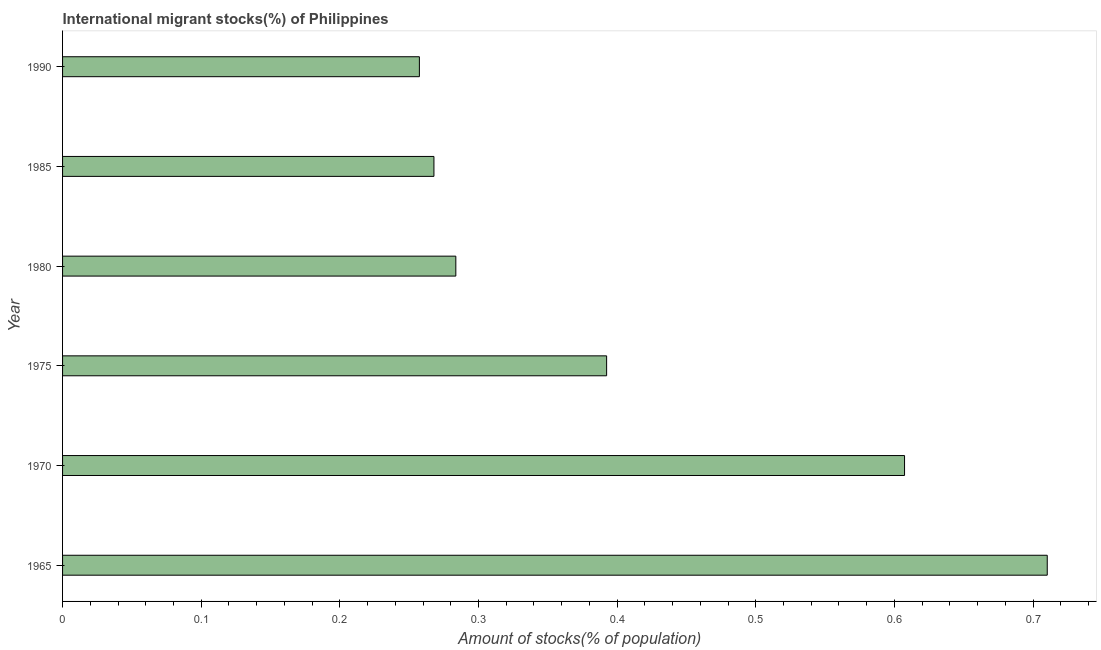Does the graph contain any zero values?
Ensure brevity in your answer.  No. Does the graph contain grids?
Keep it short and to the point. No. What is the title of the graph?
Offer a terse response. International migrant stocks(%) of Philippines. What is the label or title of the X-axis?
Ensure brevity in your answer.  Amount of stocks(% of population). What is the label or title of the Y-axis?
Offer a terse response. Year. What is the number of international migrant stocks in 1965?
Make the answer very short. 0.71. Across all years, what is the maximum number of international migrant stocks?
Ensure brevity in your answer.  0.71. Across all years, what is the minimum number of international migrant stocks?
Provide a short and direct response. 0.26. In which year was the number of international migrant stocks maximum?
Offer a terse response. 1965. In which year was the number of international migrant stocks minimum?
Offer a terse response. 1990. What is the sum of the number of international migrant stocks?
Your response must be concise. 2.52. What is the difference between the number of international migrant stocks in 1970 and 1985?
Keep it short and to the point. 0.34. What is the average number of international migrant stocks per year?
Your answer should be very brief. 0.42. What is the median number of international migrant stocks?
Your response must be concise. 0.34. Do a majority of the years between 1965 and 1970 (inclusive) have number of international migrant stocks greater than 0.54 %?
Keep it short and to the point. Yes. What is the ratio of the number of international migrant stocks in 1975 to that in 1990?
Provide a short and direct response. 1.52. Is the number of international migrant stocks in 1985 less than that in 1990?
Provide a succinct answer. No. What is the difference between the highest and the second highest number of international migrant stocks?
Provide a short and direct response. 0.1. Is the sum of the number of international migrant stocks in 1970 and 1980 greater than the maximum number of international migrant stocks across all years?
Keep it short and to the point. Yes. What is the difference between the highest and the lowest number of international migrant stocks?
Offer a terse response. 0.45. How many bars are there?
Offer a terse response. 6. Are all the bars in the graph horizontal?
Your answer should be very brief. Yes. What is the difference between two consecutive major ticks on the X-axis?
Keep it short and to the point. 0.1. What is the Amount of stocks(% of population) in 1965?
Your answer should be very brief. 0.71. What is the Amount of stocks(% of population) in 1970?
Offer a terse response. 0.61. What is the Amount of stocks(% of population) in 1975?
Your answer should be very brief. 0.39. What is the Amount of stocks(% of population) in 1980?
Your response must be concise. 0.28. What is the Amount of stocks(% of population) of 1985?
Provide a succinct answer. 0.27. What is the Amount of stocks(% of population) of 1990?
Your response must be concise. 0.26. What is the difference between the Amount of stocks(% of population) in 1965 and 1970?
Make the answer very short. 0.1. What is the difference between the Amount of stocks(% of population) in 1965 and 1975?
Give a very brief answer. 0.32. What is the difference between the Amount of stocks(% of population) in 1965 and 1980?
Provide a short and direct response. 0.43. What is the difference between the Amount of stocks(% of population) in 1965 and 1985?
Ensure brevity in your answer.  0.44. What is the difference between the Amount of stocks(% of population) in 1965 and 1990?
Your answer should be very brief. 0.45. What is the difference between the Amount of stocks(% of population) in 1970 and 1975?
Offer a very short reply. 0.21. What is the difference between the Amount of stocks(% of population) in 1970 and 1980?
Your answer should be very brief. 0.32. What is the difference between the Amount of stocks(% of population) in 1970 and 1985?
Your answer should be compact. 0.34. What is the difference between the Amount of stocks(% of population) in 1970 and 1990?
Make the answer very short. 0.35. What is the difference between the Amount of stocks(% of population) in 1975 and 1980?
Provide a short and direct response. 0.11. What is the difference between the Amount of stocks(% of population) in 1975 and 1985?
Keep it short and to the point. 0.12. What is the difference between the Amount of stocks(% of population) in 1975 and 1990?
Your answer should be very brief. 0.14. What is the difference between the Amount of stocks(% of population) in 1980 and 1985?
Offer a terse response. 0.02. What is the difference between the Amount of stocks(% of population) in 1980 and 1990?
Offer a terse response. 0.03. What is the difference between the Amount of stocks(% of population) in 1985 and 1990?
Offer a very short reply. 0.01. What is the ratio of the Amount of stocks(% of population) in 1965 to that in 1970?
Provide a succinct answer. 1.17. What is the ratio of the Amount of stocks(% of population) in 1965 to that in 1975?
Your response must be concise. 1.81. What is the ratio of the Amount of stocks(% of population) in 1965 to that in 1980?
Provide a short and direct response. 2.5. What is the ratio of the Amount of stocks(% of population) in 1965 to that in 1985?
Ensure brevity in your answer.  2.65. What is the ratio of the Amount of stocks(% of population) in 1965 to that in 1990?
Offer a very short reply. 2.76. What is the ratio of the Amount of stocks(% of population) in 1970 to that in 1975?
Give a very brief answer. 1.55. What is the ratio of the Amount of stocks(% of population) in 1970 to that in 1980?
Ensure brevity in your answer.  2.14. What is the ratio of the Amount of stocks(% of population) in 1970 to that in 1985?
Provide a succinct answer. 2.27. What is the ratio of the Amount of stocks(% of population) in 1970 to that in 1990?
Provide a succinct answer. 2.36. What is the ratio of the Amount of stocks(% of population) in 1975 to that in 1980?
Make the answer very short. 1.38. What is the ratio of the Amount of stocks(% of population) in 1975 to that in 1985?
Your answer should be very brief. 1.47. What is the ratio of the Amount of stocks(% of population) in 1975 to that in 1990?
Offer a very short reply. 1.52. What is the ratio of the Amount of stocks(% of population) in 1980 to that in 1985?
Your response must be concise. 1.06. What is the ratio of the Amount of stocks(% of population) in 1980 to that in 1990?
Your response must be concise. 1.1. What is the ratio of the Amount of stocks(% of population) in 1985 to that in 1990?
Offer a terse response. 1.04. 